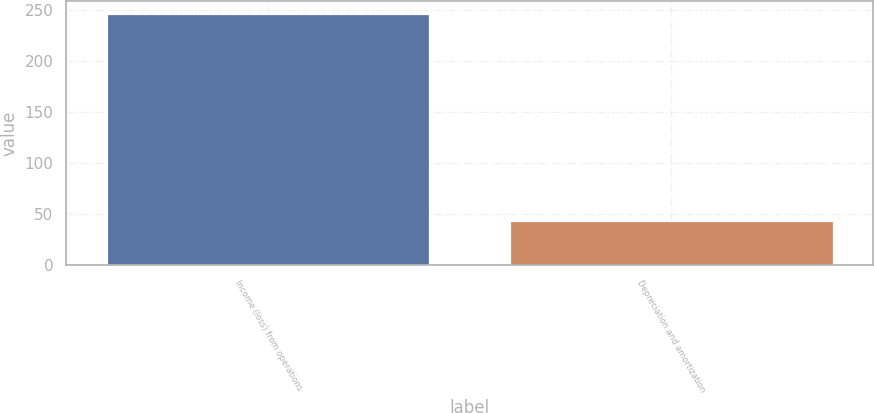Convert chart to OTSL. <chart><loc_0><loc_0><loc_500><loc_500><bar_chart><fcel>Income (loss) from operations<fcel>Depreciation and amortization<nl><fcel>246.5<fcel>43.8<nl></chart> 